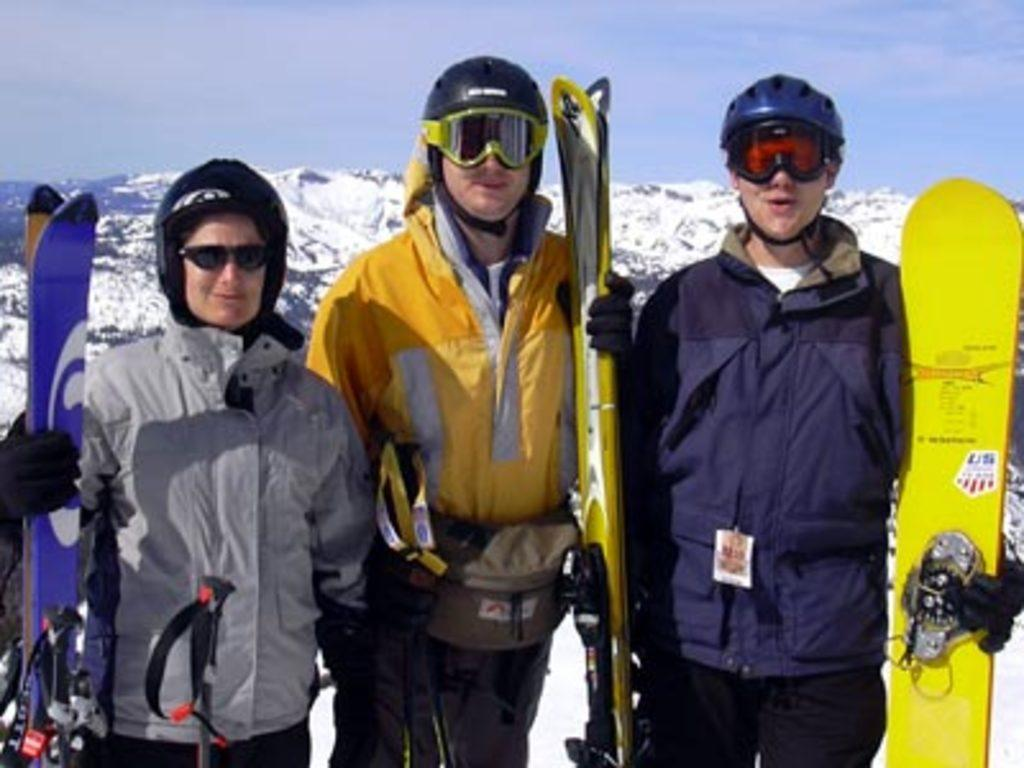How many people are in the image? There are three people standing in the front of the image. What are the people wearing? The people are wearing jackets. What are the people holding in their hands? The people are holding boards. What is the weather like in the image? The sky in the background is snowy and cloudy. What type of glue is being used to attach the form to the jar in the image? There is no form, glue, or jar present in the image. 